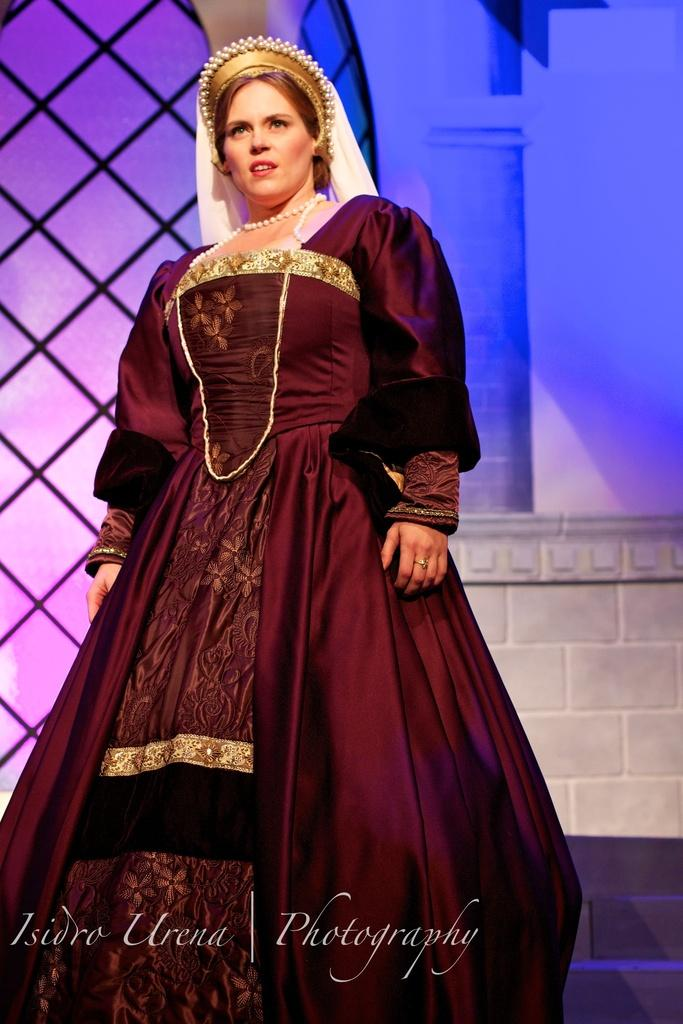What is the main subject of the image? There is a person standing in the image. What is the person wearing? The person is wearing a maroon color dress. What accessory is the person wearing on their head? The person is wearing a crown. What can be seen in the background of the image? There is a wall visible in the background of the image. How many spots can be seen on the person's dress in the image? There are no spots visible on the person's dress in the image; it is a solid maroon color. What wish does the person make while wearing the crown in the image? There is no indication of a wish being made in the image; the person is simply wearing a crown. 